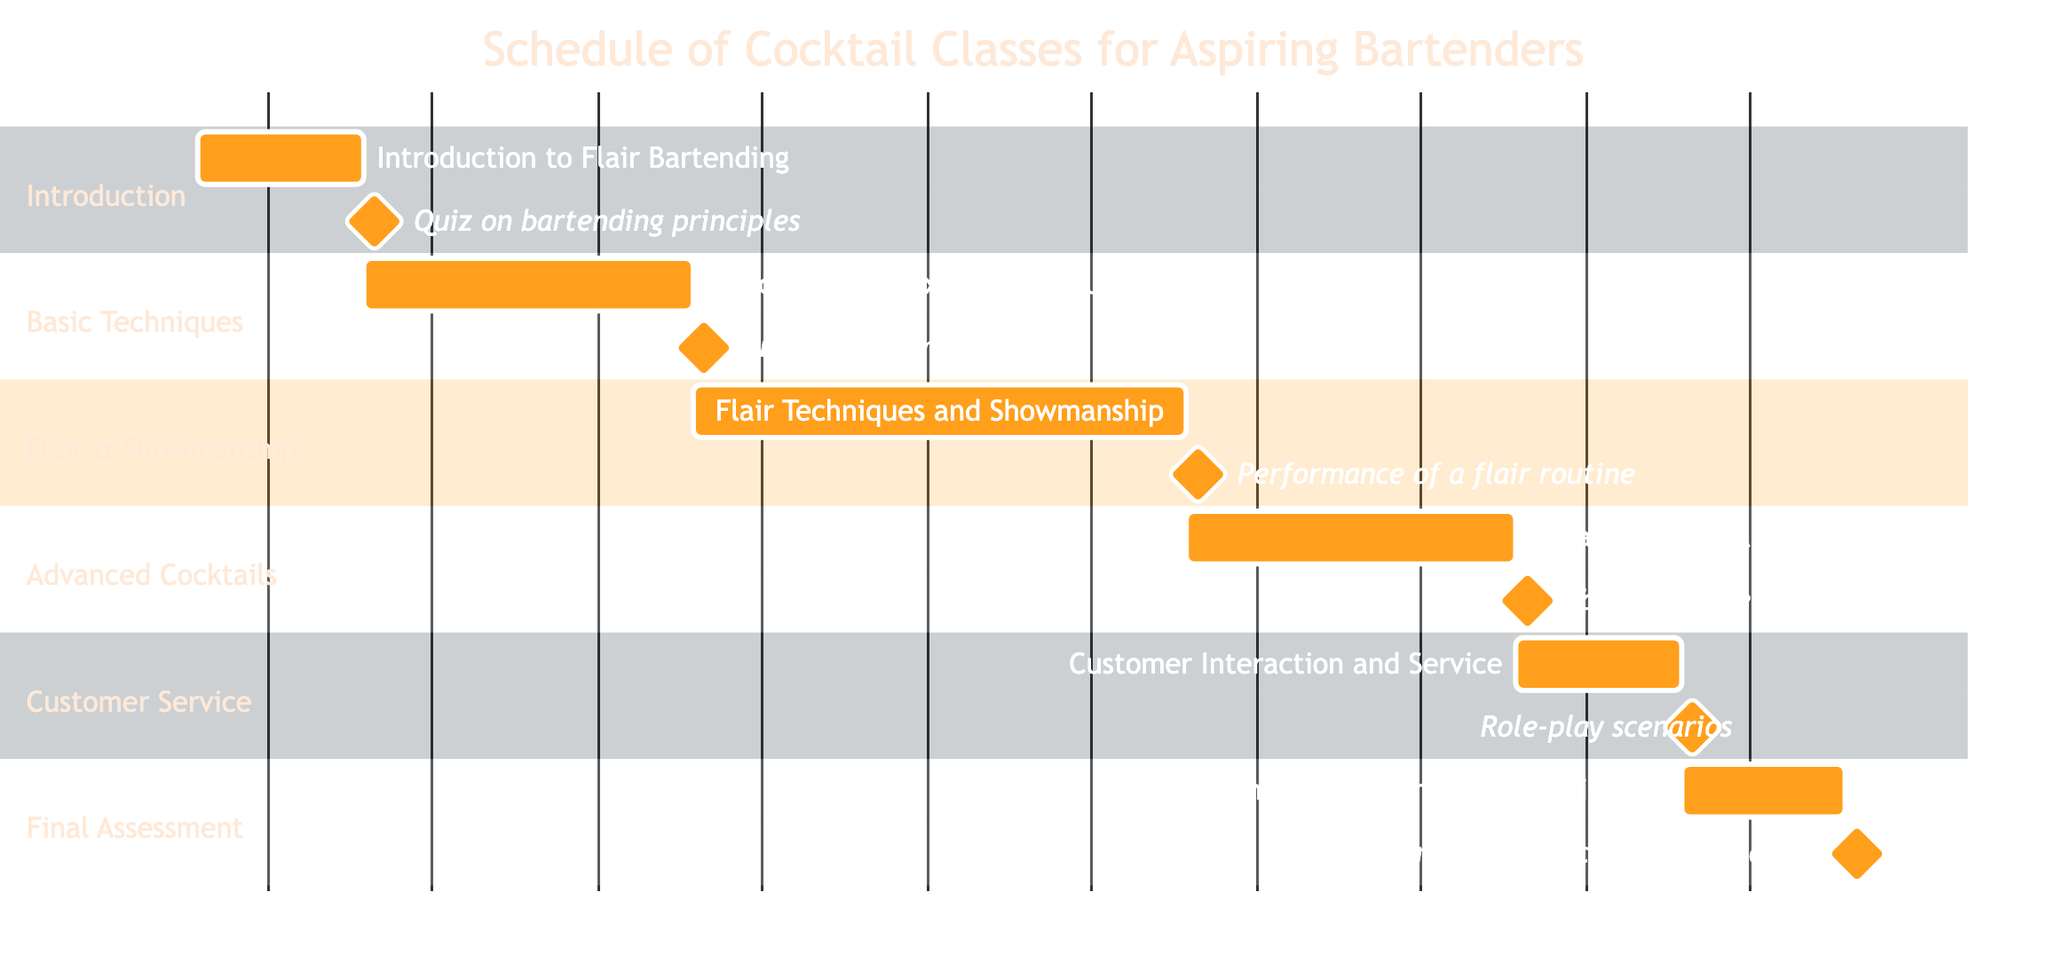What is the duration of the "Introduction to Flair Bartending"? The task "Introduction to Flair Bartending" in the Gantt chart is noted as lasting for "1 week". This information can be found directly next to the corresponding task in the diagram.
Answer: 1 week How many milestones are associated with "Flair Techniques and Showmanship"? For the task "Flair Techniques and Showmanship", there are two milestones listed: "Learn basic flair moves" and "Practice showmanship skills". The count of milestones is obtained by examining the listed milestones under the task in the chart.
Answer: 2 What task comes after "Customer Interaction and Service"? "Final Assessment and Certification" follows "Customer Interaction and Service" in the schedule. This relationship is shown by the placement of the tasks in sequence within the Gantt chart, where one task is set to start after the completion of another.
Answer: Final Assessment and Certification What is the evaluation method for the "Advanced Cocktail Recipes"? The evaluation method mentioned for the "Advanced Cocktail Recipes" is "Tasting and feedback session". This can be identified by looking for the evaluation component listed under this specific task in the Gantt chart.
Answer: Tasting and feedback session Which task has the longest duration across the schedule? The task with the longest duration is "Flair Techniques and Showmanship", lasting for "3 weeks". By comparing the durations for each listed task in the Gantt chart, this task stands out as the longest duration.
Answer: 3 weeks What are the two main components evaluated throughout the "Final Assessment and Certification"? The two main components for evaluation in the "Final Assessment and Certification" are "Culminating practical exam" and "Present flair routine and cocktail creations". This information is gathered from the evaluation section under the specified task in the chart.
Answer: Culminating practical exam and Present flair routine and cocktail creations How many total tasks are outlined in the schedule? There are six tasks outlined in the schedule: Introduction to Flair Bartending, Basic Cocktail Mixing Techniques, Flair Techniques and Showmanship, Advanced Cocktail Recipes, Customer Interaction and Service, and Final Assessment and Certification. Counting these tasks gives the total number of tasks in the Gantt chart.
Answer: 6 Which task requires the least time commitment? The task that requires the least time commitment is "Introduction to Flair Bartending", which only takes "1 week". This can be confirmed by reviewing the duration of each task in the Gantt chart.
Answer: 1 week 